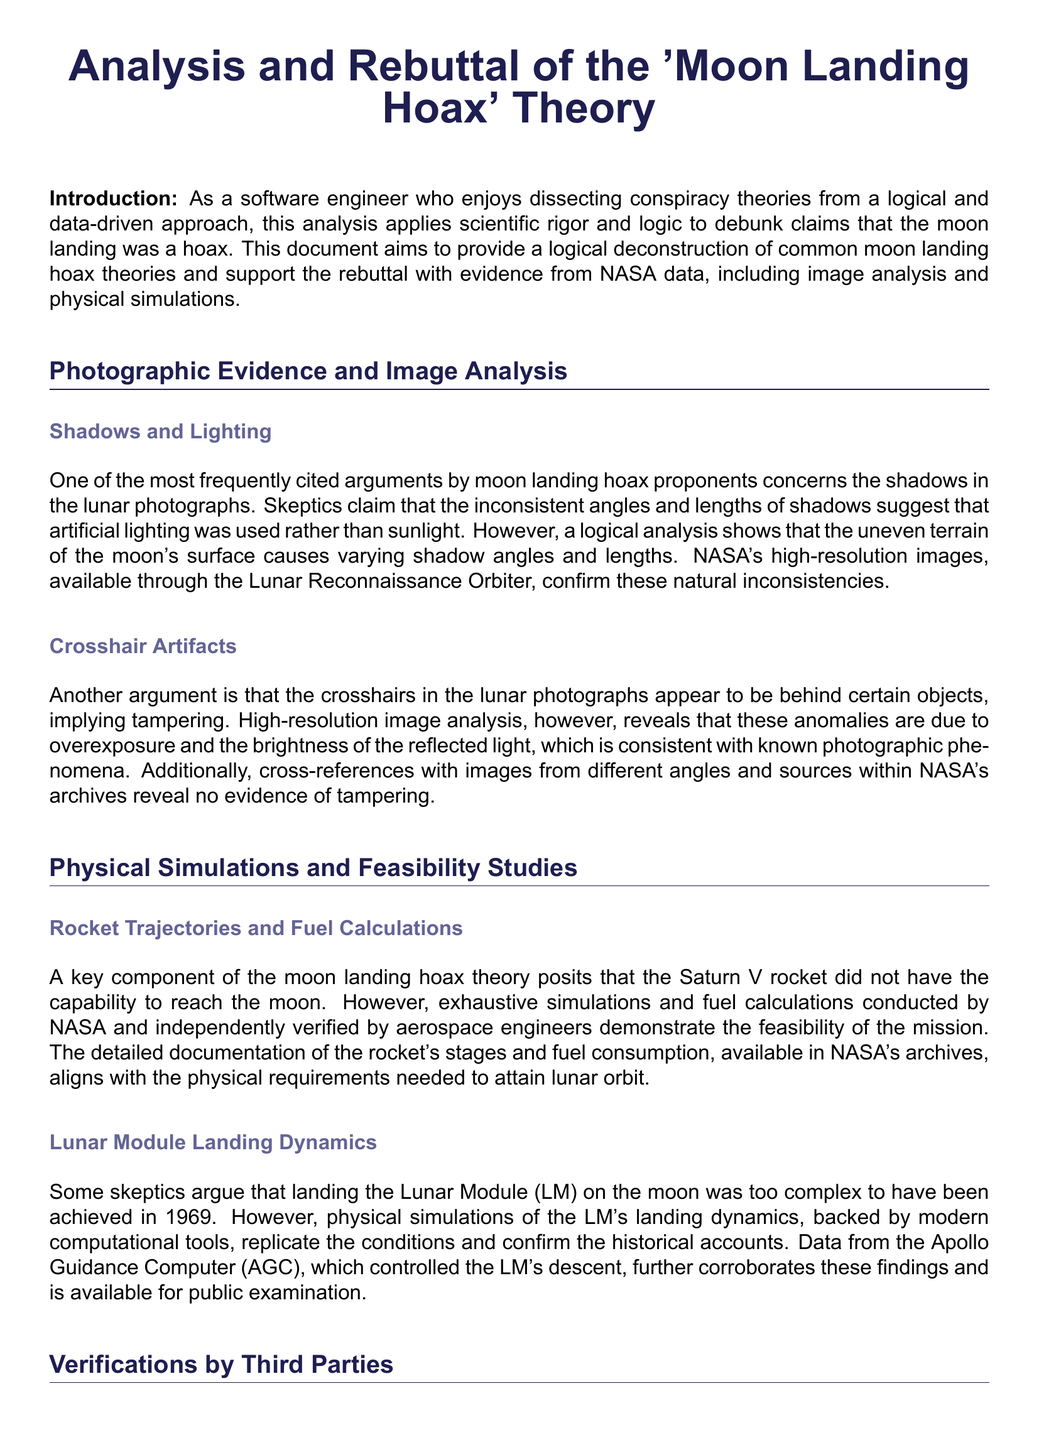What is the title of the document? The title is the main heading that describes the content, which is "Analysis and Rebuttal of the 'Moon Landing Hoax' Theory."
Answer: Analysis and Rebuttal of the 'Moon Landing Hoax' Theory Who conducted the physical simulations of the Lunar Module's landing dynamics? The document mentions NASA and independently verified aerospace engineers as having conducted these simulations.
Answer: NASA and aerospace engineers What photographic evidence is discussed in the document? The document refers to high-resolution images from the Lunar Reconnaissance Orbiter as a key piece of photographic evidence.
Answer: Lunar Reconnaissance Orbiter What element of the Apollo missions is mentioned regarding independent verification? The document states that tracking stations in the Soviet Union independently verified the Apollo missions.
Answer: Soviet Union's tracking stations How are retroreflectors used today? The document explains that retroreflectors are used for precise Earth-moon distance measurements via laser ranging experiments.
Answer: Earth-moon distance measurements What is the purpose of the analysis in the document? The document aims to apply scientific rigor and logic to debunk claims that the moon landing was a hoax.
Answer: To debunk claims What type of analysis is emphasized to support the rebuttal? The document emphasizes the use of logical analysis, image verification, physical simulations, and third-party confirmations.
Answer: Logical analysis, image verification, physical simulations, third-party confirmations How are the inconsistencies in lunar photographs explained? The document explains that the inconsistencies in shadows are due to the uneven terrain of the moon's surface.
Answer: Uneven terrain of the moon's surface What acts as a source of tangible proof of human activity on the moon? The retroreflectors placed on the lunar surface serve as tangible proof of human activity according to the document.
Answer: Retroreflectors 